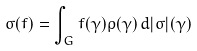<formula> <loc_0><loc_0><loc_500><loc_500>\sigma ( f ) = \int _ { G } f ( \gamma ) \rho ( \gamma ) \, d | \sigma | ( \gamma )</formula> 